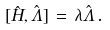Convert formula to latex. <formula><loc_0><loc_0><loc_500><loc_500>[ \hat { H } , \hat { \Lambda } ] \, = \, \lambda \hat { \Lambda } \, .</formula> 